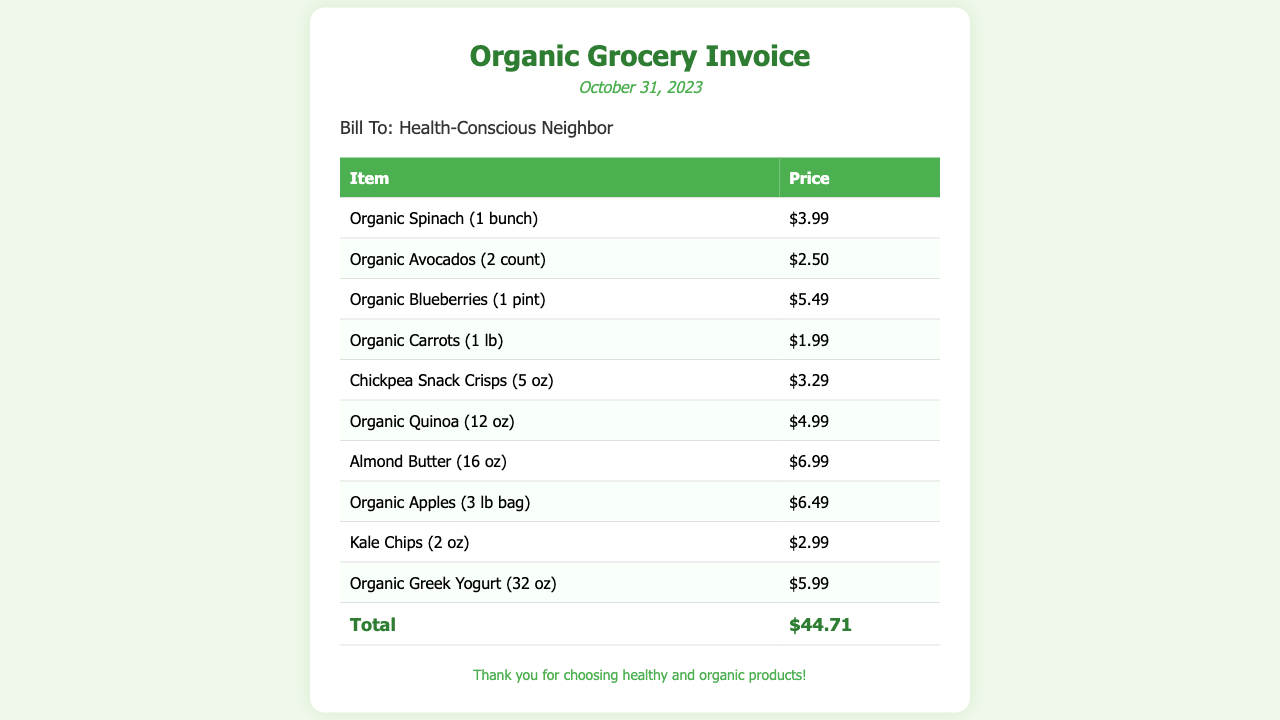What is the date of the invoice? The date of the invoice is specifically mentioned at the top of the document.
Answer: October 31, 2023 Who is the bill addressed to? The invoice clearly states the recipient's name in the buyer info section.
Answer: Health-Conscious Neighbor What is the price of Organic Blueberries? The price is listed next to the item in the items table.
Answer: $5.49 How many pounds of Organic Apples are included in the purchase? The weight of the Organic Apples is indicated in the item description.
Answer: 3 lb What is the total amount of the invoice? The total amount is shown at the bottom of the items table as the final tally.
Answer: $44.71 Which item costs the most? To find this, we look for the highest price in the itemized list.
Answer: Almond Butter How many snacks are included in the invoice? We can determine this by counting the number of snack-related items in the list.
Answer: 2 What type of yogurt is purchased? The invoice specifies the type of yogurt in the item description.
Answer: Organic Greek Yogurt What is the weight of the Kale Chips? The weight is noted next to the item in the items table.
Answer: 2 oz 